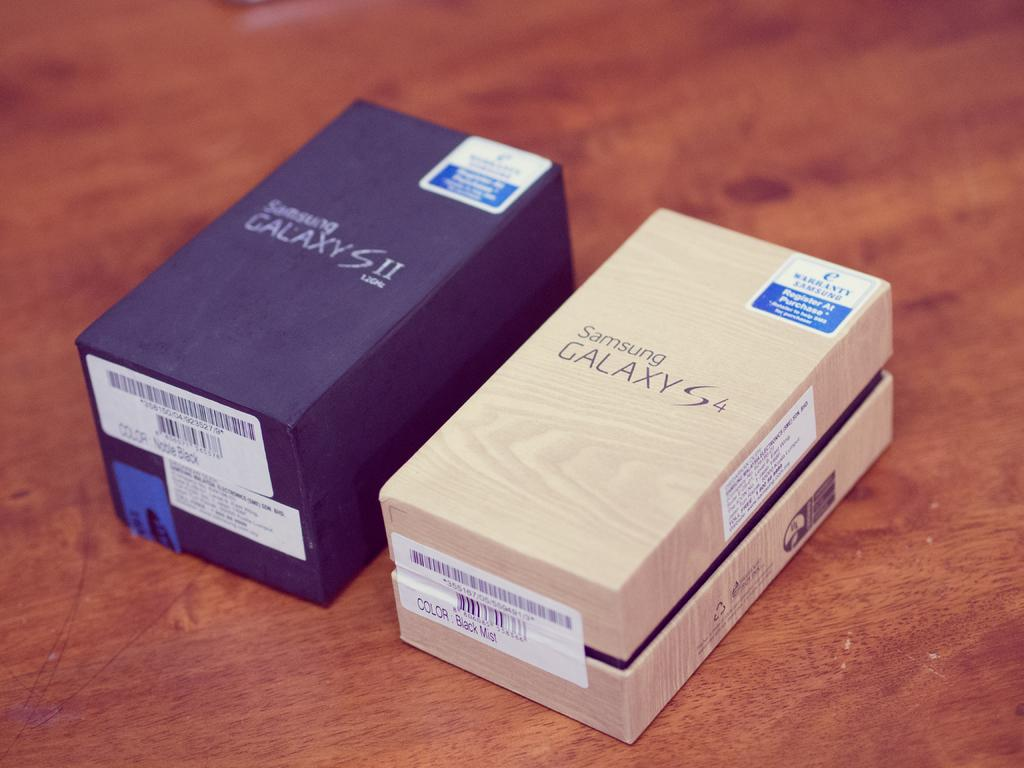What objects are on the wooden surface in the image? There are boxes on a wooden surface in the image. What can be seen on the boxes? The boxes have stickers on them. What type of observation can be made about the queen's behavior on stage in the image? There is no queen or stage present in the image; it only features boxes with stickers on a wooden surface. 